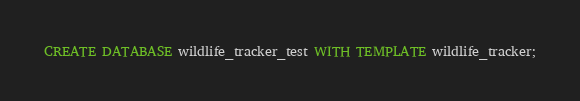<code> <loc_0><loc_0><loc_500><loc_500><_SQL_>CREATE DATABASE wildlife_tracker_test WITH TEMPLATE wildlife_tracker;
</code> 